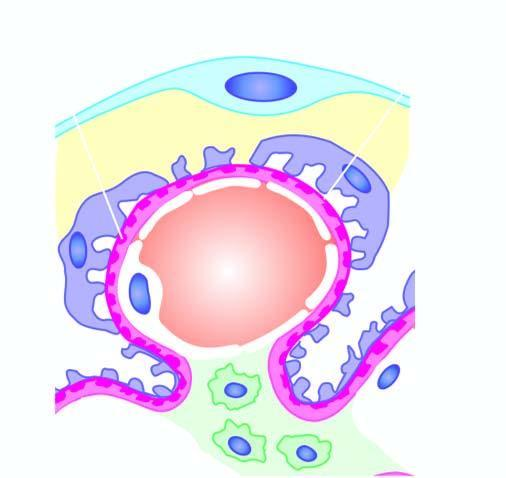does onsumption of tobacco in india protrude?
Answer the question using a single word or phrase. No 